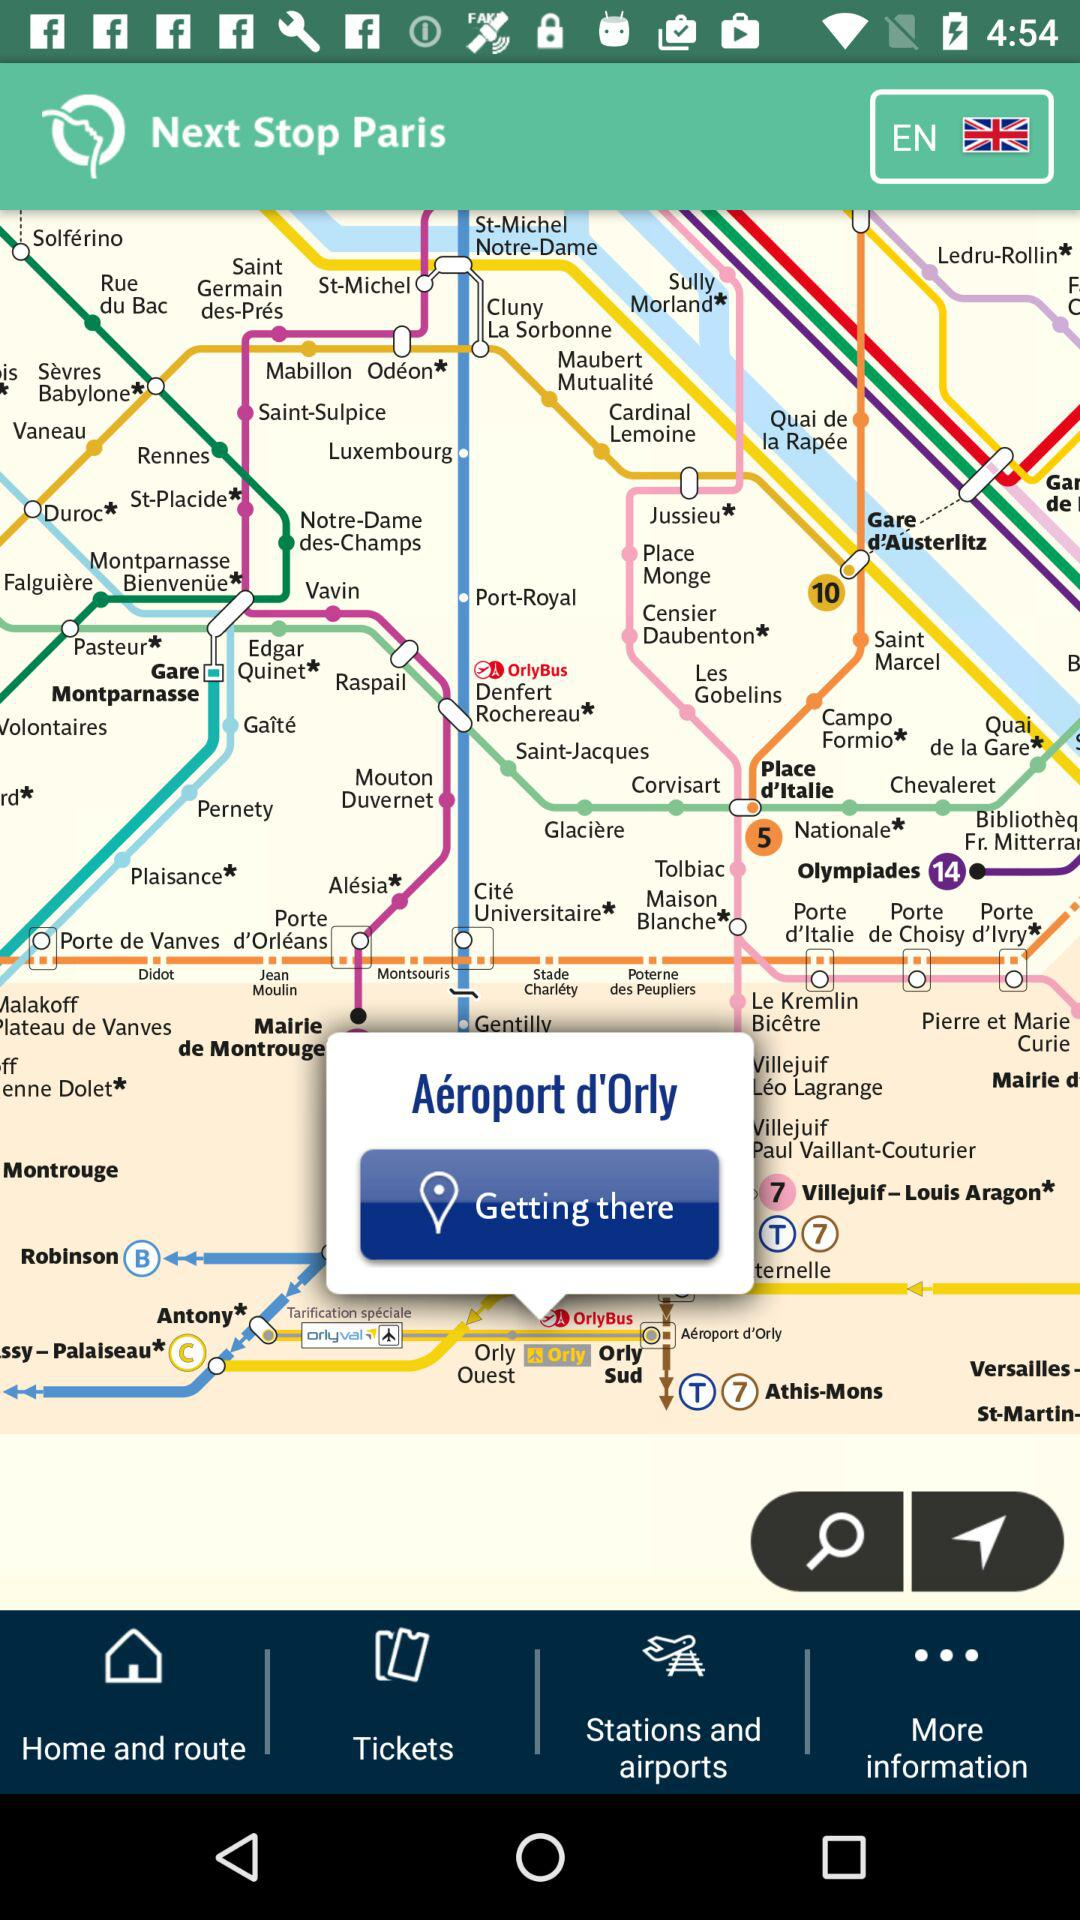Which country is selected? The selected country is the United Kingdom. 